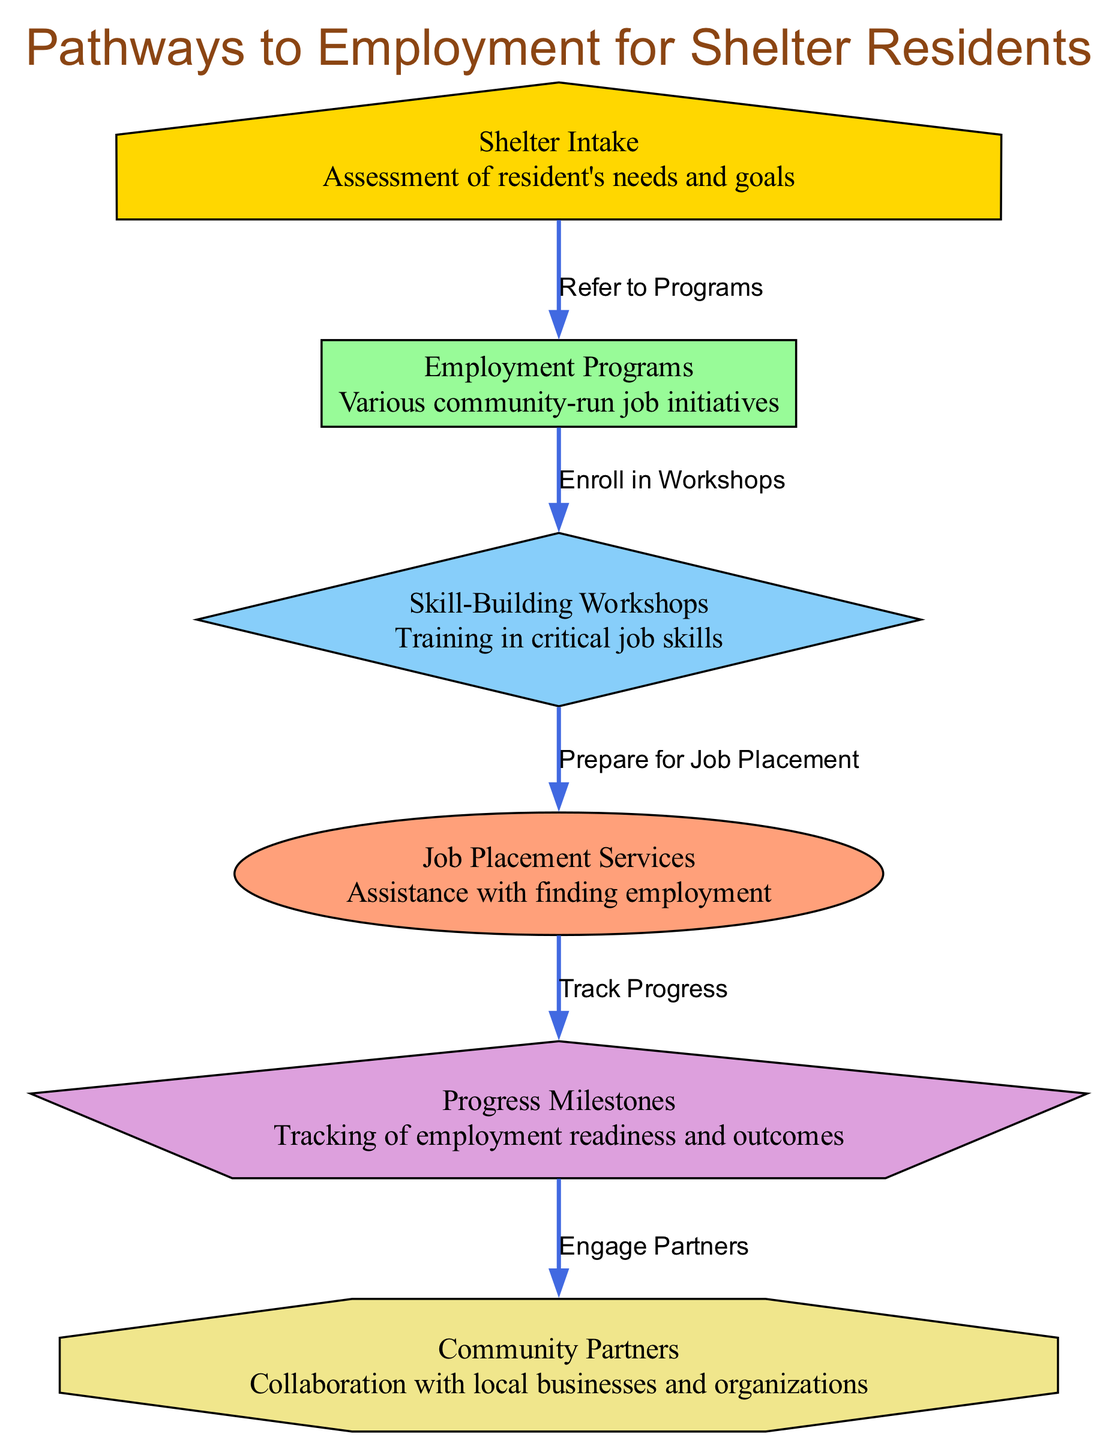What is the first step in the pathway to employment? The first step in the pathway to employment is the "Shelter Intake," where the resident's needs and goals are assessed.
Answer: Shelter Intake How many nodes are displayed in the diagram? There are a total of 6 nodes in the diagram: "Shelter Intake," "Employment Programs," "Skill-Building Workshops," "Job Placement Services," "Progress Milestones," and "Community Partners."
Answer: 6 What label connects "Employment Programs" to "Skill-Building Workshops"? The label that connects "Employment Programs" to "Skill-Building Workshops" is "Enroll in Workshops."
Answer: Enroll in Workshops What is the purpose of "Progress Milestones"? The purpose of "Progress Milestones" is to track employment readiness and outcomes for the residents.
Answer: Tracking of employment readiness and outcomes What node comes directly after "Job Placement Services"? The node that comes directly after "Job Placement Services" is "Progress Milestones."
Answer: Progress Milestones What relationship does "Progress Milestones" have with "Community Partners"? The relationship is "Engage Partners," indicating collaboration and engagement with local businesses and organizations.
Answer: Engage Partners Which node follows "Skill-Building Workshops"? The node that follows "Skill-Building Workshops" is "Job Placement Services."
Answer: Job Placement Services What is the last milestone in the pathway to employment? The last milestone in the pathway is "Community Partners."
Answer: Community Partners How does a resident move from "Shelter Intake" to "Job Placement Services"? A resident moves from "Shelter Intake" to "Job Placement Services" by first being referred to "Employment Programs," then enrolling in "Skill-Building Workshops," which prepares them for "Job Placement Services."
Answer: Through referrals and enrollments 